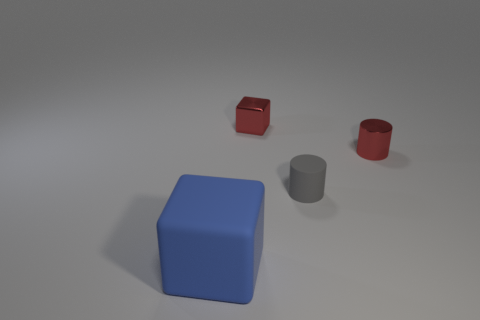Subtract all gray cylinders. How many cylinders are left? 1 Subtract 1 blocks. How many blocks are left? 1 Subtract all large blue cubes. Subtract all tiny cyan rubber cylinders. How many objects are left? 3 Add 1 small red things. How many small red things are left? 3 Add 1 matte balls. How many matte balls exist? 1 Add 2 big gray matte cylinders. How many objects exist? 6 Subtract 1 gray cylinders. How many objects are left? 3 Subtract all red cubes. Subtract all yellow spheres. How many cubes are left? 1 Subtract all cyan blocks. How many gray cylinders are left? 1 